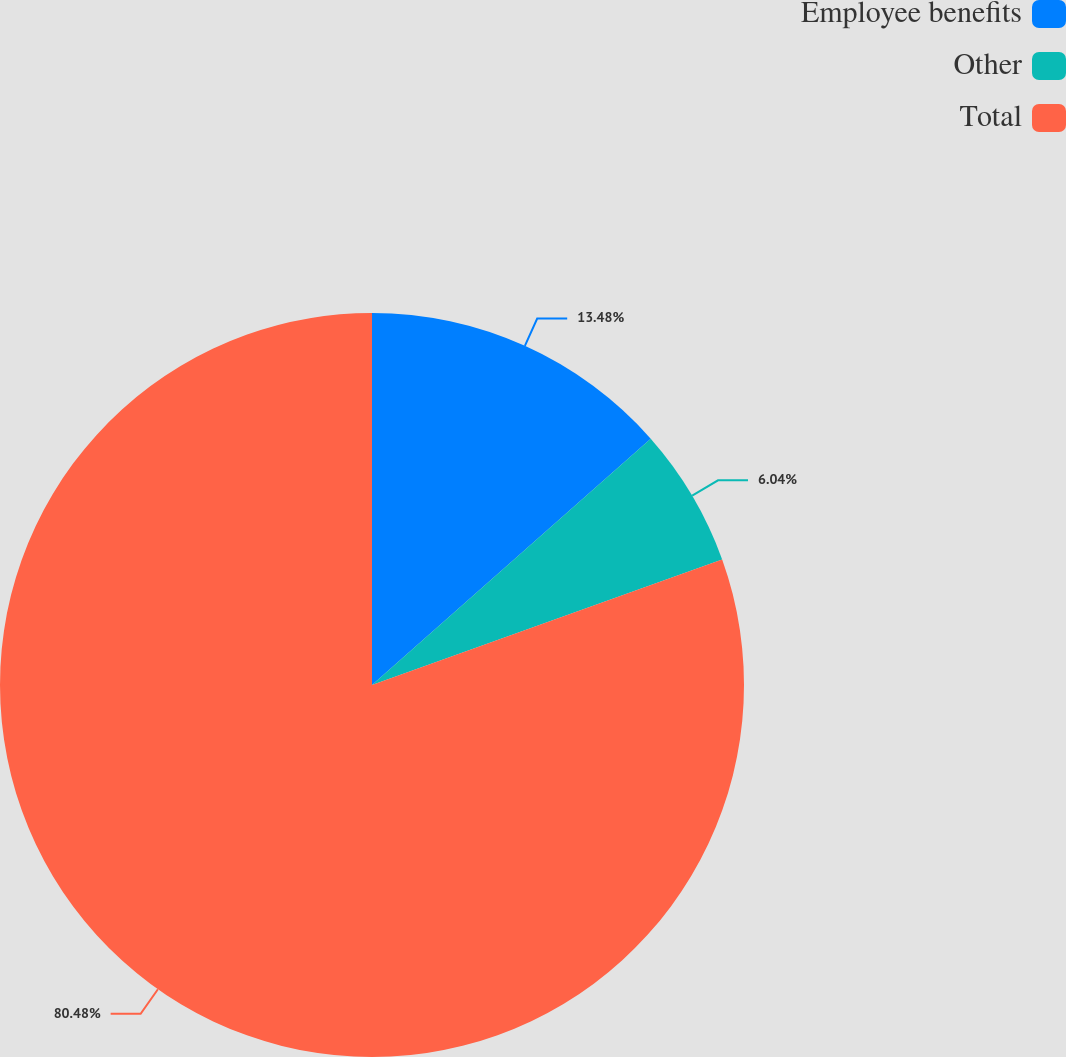Convert chart to OTSL. <chart><loc_0><loc_0><loc_500><loc_500><pie_chart><fcel>Employee benefits<fcel>Other<fcel>Total<nl><fcel>13.48%<fcel>6.04%<fcel>80.48%<nl></chart> 